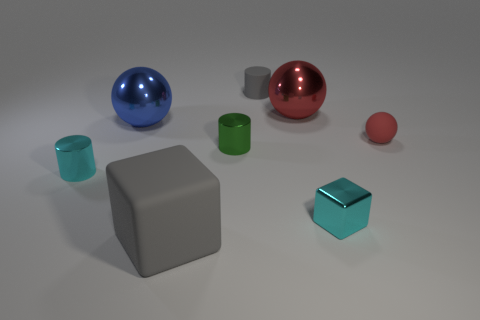Add 1 matte balls. How many objects exist? 9 Subtract all cubes. How many objects are left? 6 Subtract 1 cyan blocks. How many objects are left? 7 Subtract all tiny red matte things. Subtract all gray cylinders. How many objects are left? 6 Add 2 small blocks. How many small blocks are left? 3 Add 8 large red shiny things. How many large red shiny things exist? 9 